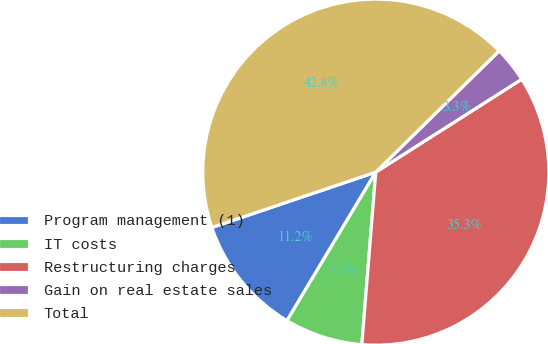Convert chart. <chart><loc_0><loc_0><loc_500><loc_500><pie_chart><fcel>Program management (1)<fcel>IT costs<fcel>Restructuring charges<fcel>Gain on real estate sales<fcel>Total<nl><fcel>11.24%<fcel>7.29%<fcel>35.31%<fcel>3.34%<fcel>42.82%<nl></chart> 